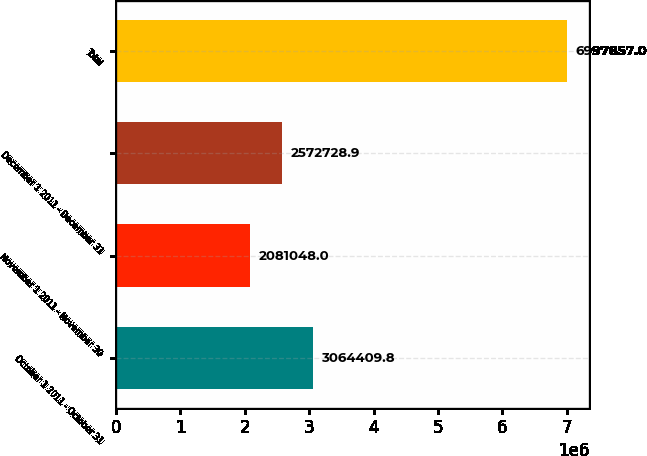Convert chart to OTSL. <chart><loc_0><loc_0><loc_500><loc_500><bar_chart><fcel>October 1 2011 - October 31<fcel>November 1 2011 - November 30<fcel>December 1 2011 - December 31<fcel>Total<nl><fcel>3.06441e+06<fcel>2.08105e+06<fcel>2.57273e+06<fcel>6.99786e+06<nl></chart> 